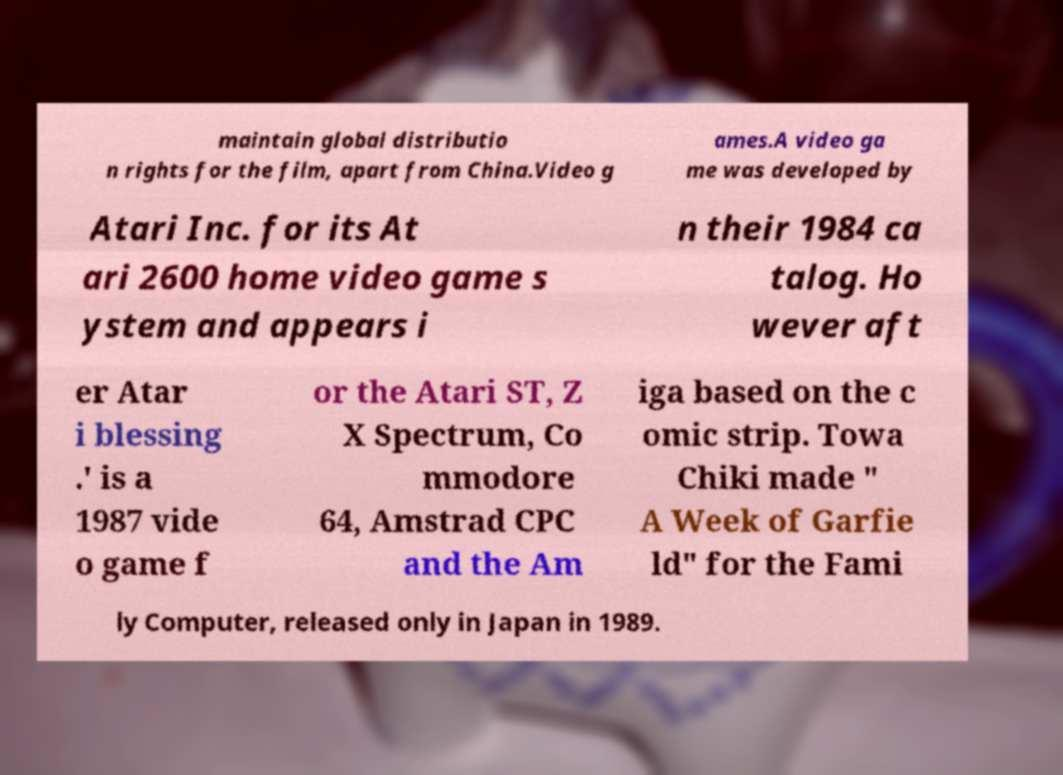Could you extract and type out the text from this image? maintain global distributio n rights for the film, apart from China.Video g ames.A video ga me was developed by Atari Inc. for its At ari 2600 home video game s ystem and appears i n their 1984 ca talog. Ho wever aft er Atar i blessing .' is a 1987 vide o game f or the Atari ST, Z X Spectrum, Co mmodore 64, Amstrad CPC and the Am iga based on the c omic strip. Towa Chiki made " A Week of Garfie ld" for the Fami ly Computer, released only in Japan in 1989. 